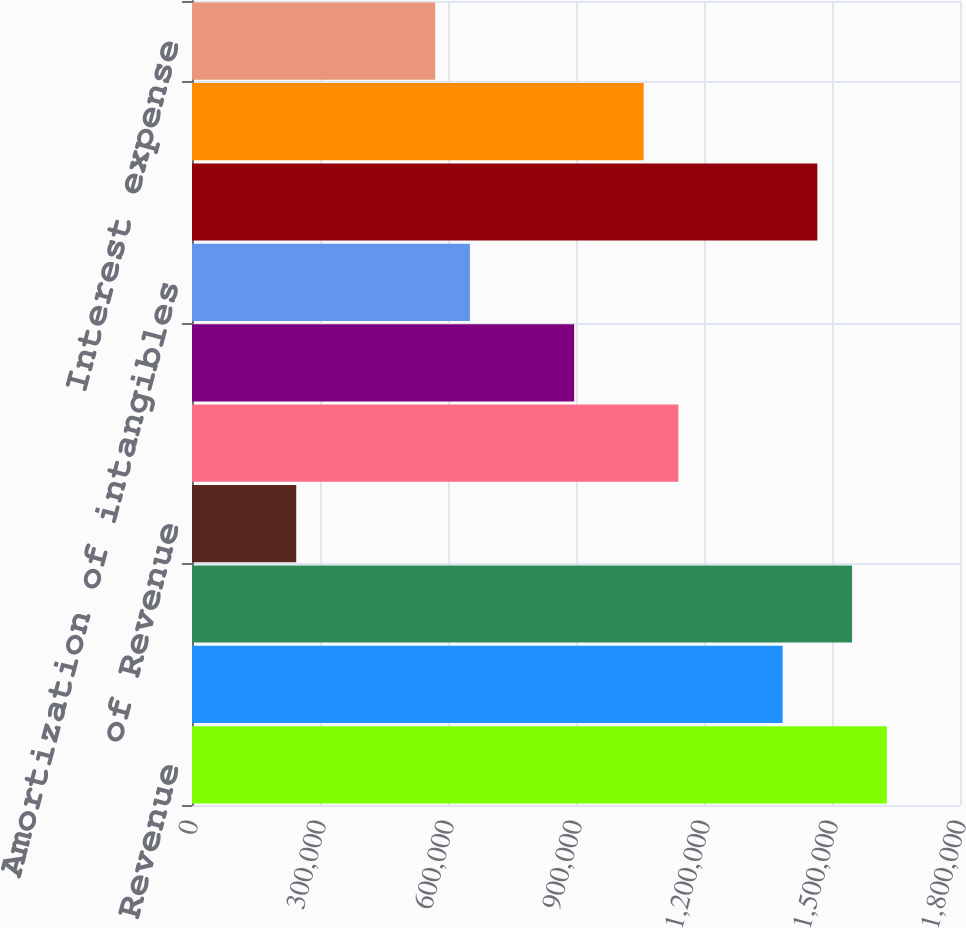Convert chart to OTSL. <chart><loc_0><loc_0><loc_500><loc_500><bar_chart><fcel>Revenue<fcel>Cost of sales (a)<fcel>Gross margin<fcel>of Revenue<fcel>Research and development<fcel>Selling marketing general and<fcel>Amortization of intangibles<fcel>Total operating expenses<fcel>Operating income<fcel>Interest expense<nl><fcel>1.62849e+06<fcel>1.38422e+06<fcel>1.54707e+06<fcel>244274<fcel>1.13995e+06<fcel>895672<fcel>651398<fcel>1.46564e+06<fcel>1.05852e+06<fcel>569973<nl></chart> 